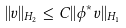Convert formula to latex. <formula><loc_0><loc_0><loc_500><loc_500>| | v | | _ { H _ { 2 } } \leq C | | \phi ^ { * } v | | _ { H _ { 1 } }</formula> 